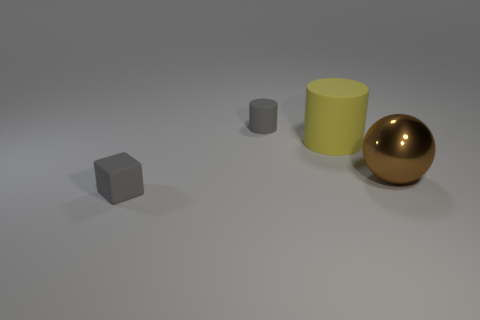If these objects had to represent a family, what roles might they play based on their size and color? If we were to personify the objects, the small gray cube could be a child given its smaller size, the larger gray cylinder might be a teenager, the big yellow cylinder the parent, and the golden sphere could represent a grandparent or a revered elder due to its standout shiny appearance. 